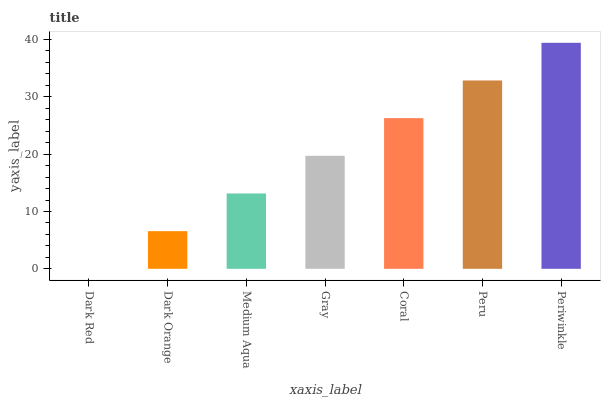Is Dark Red the minimum?
Answer yes or no. Yes. Is Periwinkle the maximum?
Answer yes or no. Yes. Is Dark Orange the minimum?
Answer yes or no. No. Is Dark Orange the maximum?
Answer yes or no. No. Is Dark Orange greater than Dark Red?
Answer yes or no. Yes. Is Dark Red less than Dark Orange?
Answer yes or no. Yes. Is Dark Red greater than Dark Orange?
Answer yes or no. No. Is Dark Orange less than Dark Red?
Answer yes or no. No. Is Gray the high median?
Answer yes or no. Yes. Is Gray the low median?
Answer yes or no. Yes. Is Coral the high median?
Answer yes or no. No. Is Dark Orange the low median?
Answer yes or no. No. 